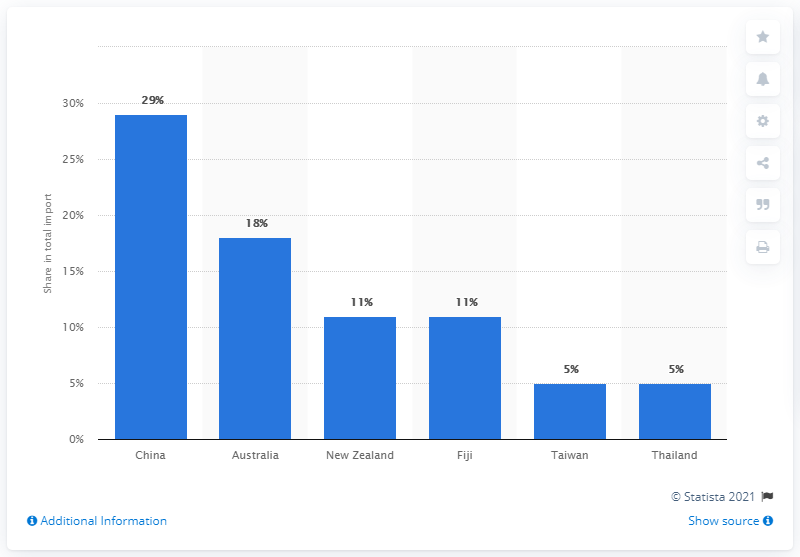Outline some significant characteristics in this image. In 2019, China was the most important import partner for Vanuatu. 